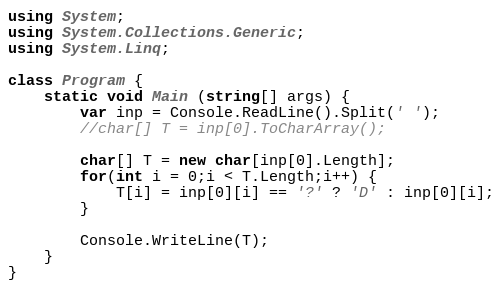<code> <loc_0><loc_0><loc_500><loc_500><_C#_>using System;
using System.Collections.Generic;
using System.Linq;

class Program {
    static void Main (string[] args) {
        var inp = Console.ReadLine().Split(' ');
        //char[] T = inp[0].ToCharArray();

        char[] T = new char[inp[0].Length];
        for(int i = 0;i < T.Length;i++) {
            T[i] = inp[0][i] == '?' ? 'D' : inp[0][i];
        }

        Console.WriteLine(T);
    }
}</code> 